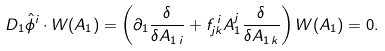<formula> <loc_0><loc_0><loc_500><loc_500>D _ { 1 } \hat { \phi } ^ { i } \cdot W ( A _ { 1 } ) = \left ( \partial _ { 1 } \frac { \delta } { \delta A _ { 1 \, i } } + f _ { j k } ^ { \, i } A _ { 1 } ^ { j } \frac { \delta } { \delta A _ { 1 \, k } } \right ) W ( A _ { 1 } ) = 0 .</formula> 